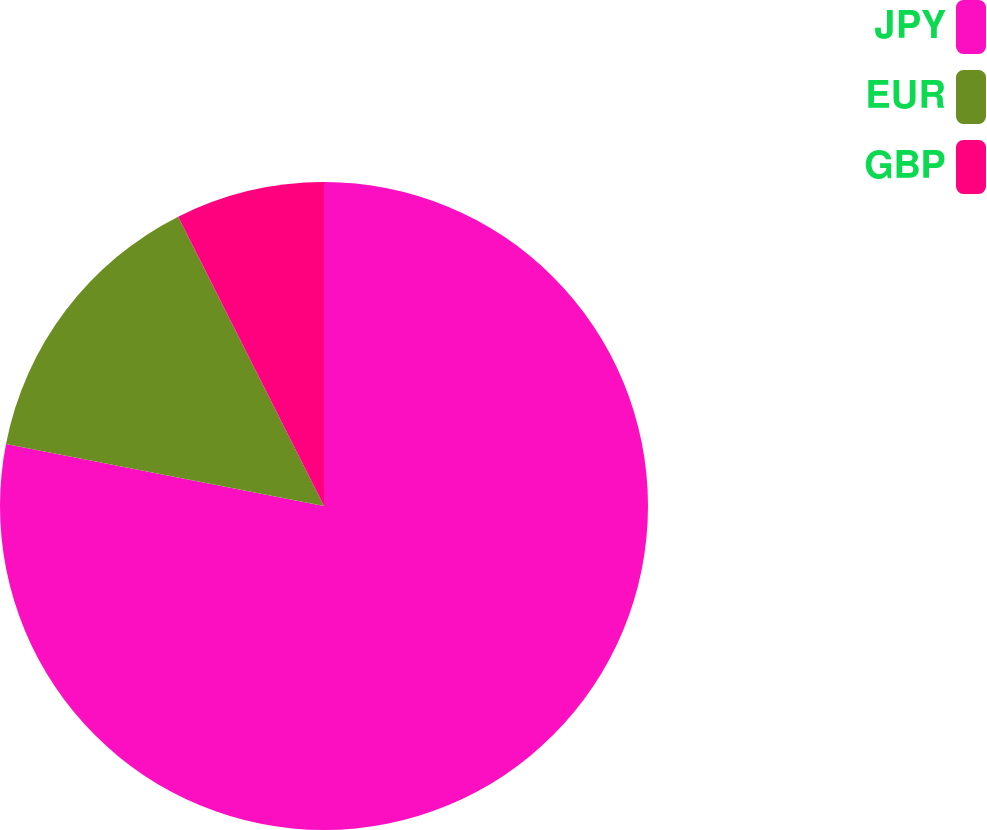Convert chart to OTSL. <chart><loc_0><loc_0><loc_500><loc_500><pie_chart><fcel>JPY<fcel>EUR<fcel>GBP<nl><fcel>78.07%<fcel>14.5%<fcel>7.43%<nl></chart> 